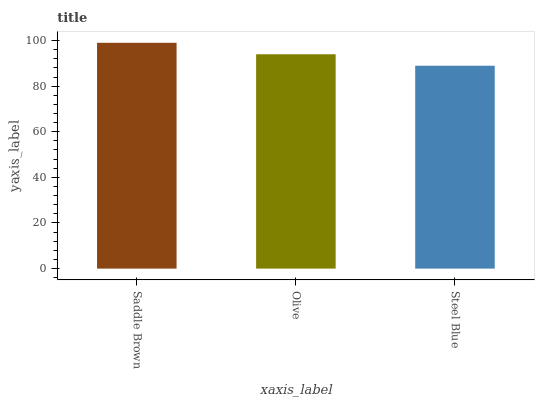Is Olive the minimum?
Answer yes or no. No. Is Olive the maximum?
Answer yes or no. No. Is Saddle Brown greater than Olive?
Answer yes or no. Yes. Is Olive less than Saddle Brown?
Answer yes or no. Yes. Is Olive greater than Saddle Brown?
Answer yes or no. No. Is Saddle Brown less than Olive?
Answer yes or no. No. Is Olive the high median?
Answer yes or no. Yes. Is Olive the low median?
Answer yes or no. Yes. Is Saddle Brown the high median?
Answer yes or no. No. Is Steel Blue the low median?
Answer yes or no. No. 